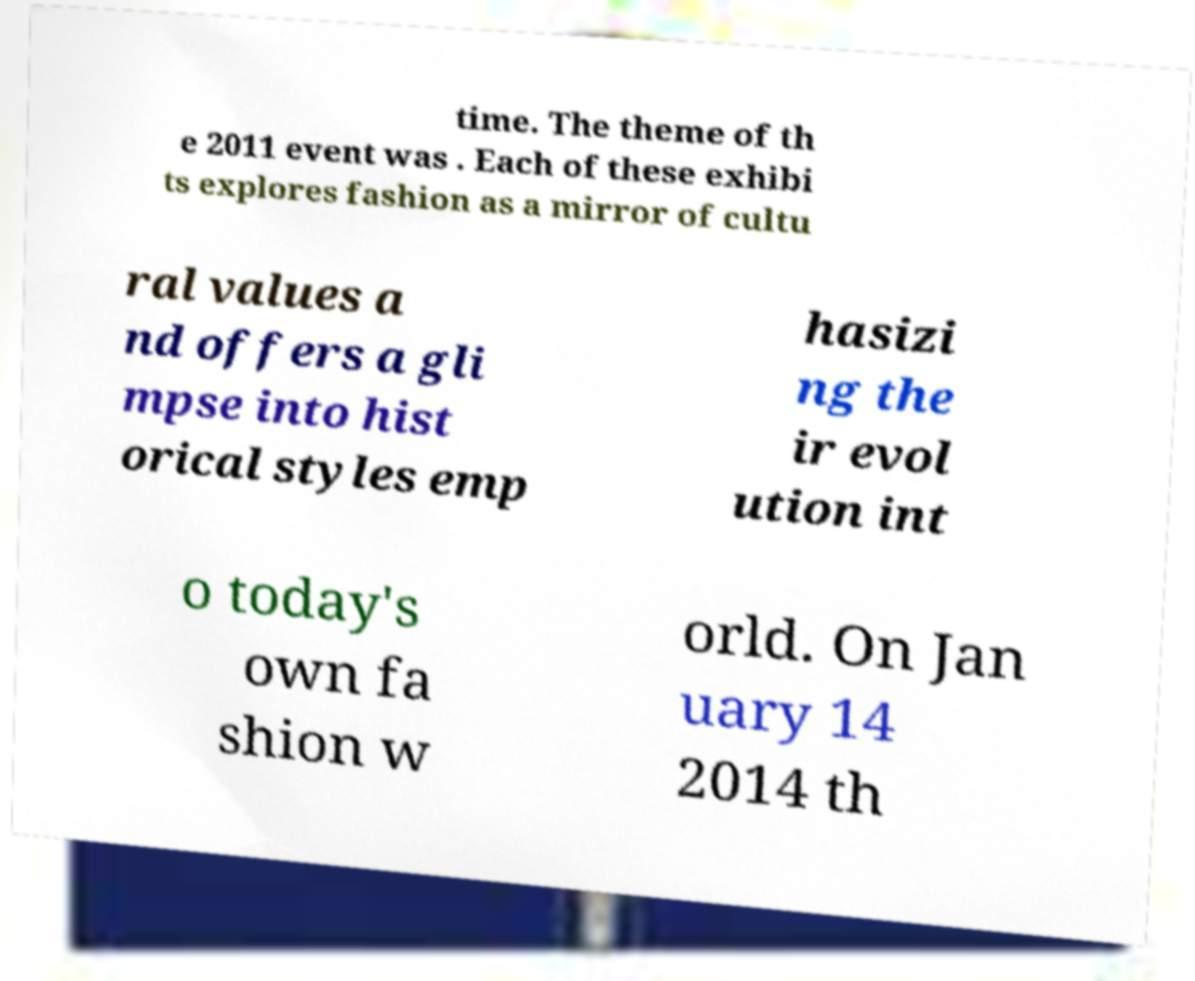Please read and relay the text visible in this image. What does it say? time. The theme of th e 2011 event was . Each of these exhibi ts explores fashion as a mirror of cultu ral values a nd offers a gli mpse into hist orical styles emp hasizi ng the ir evol ution int o today's own fa shion w orld. On Jan uary 14 2014 th 